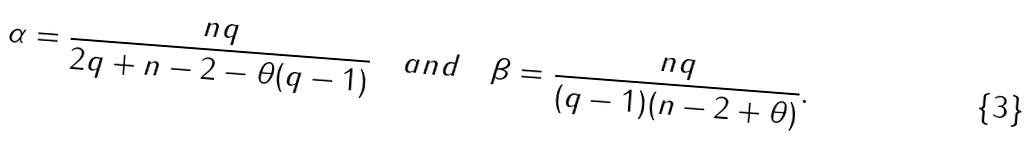Convert formula to latex. <formula><loc_0><loc_0><loc_500><loc_500>\alpha = \frac { n q } { 2 q + n - 2 - \theta ( q - 1 ) } \quad a n d \quad \beta = \frac { n q } { ( q - 1 ) ( n - 2 + \theta ) } .</formula> 